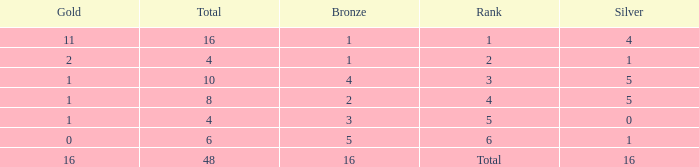Can you give me this table as a dict? {'header': ['Gold', 'Total', 'Bronze', 'Rank', 'Silver'], 'rows': [['11', '16', '1', '1', '4'], ['2', '4', '1', '2', '1'], ['1', '10', '4', '3', '5'], ['1', '8', '2', '4', '5'], ['1', '4', '3', '5', '0'], ['0', '6', '5', '6', '1'], ['16', '48', '16', 'Total', '16']]} How many total gold are less than 4? 0.0. 